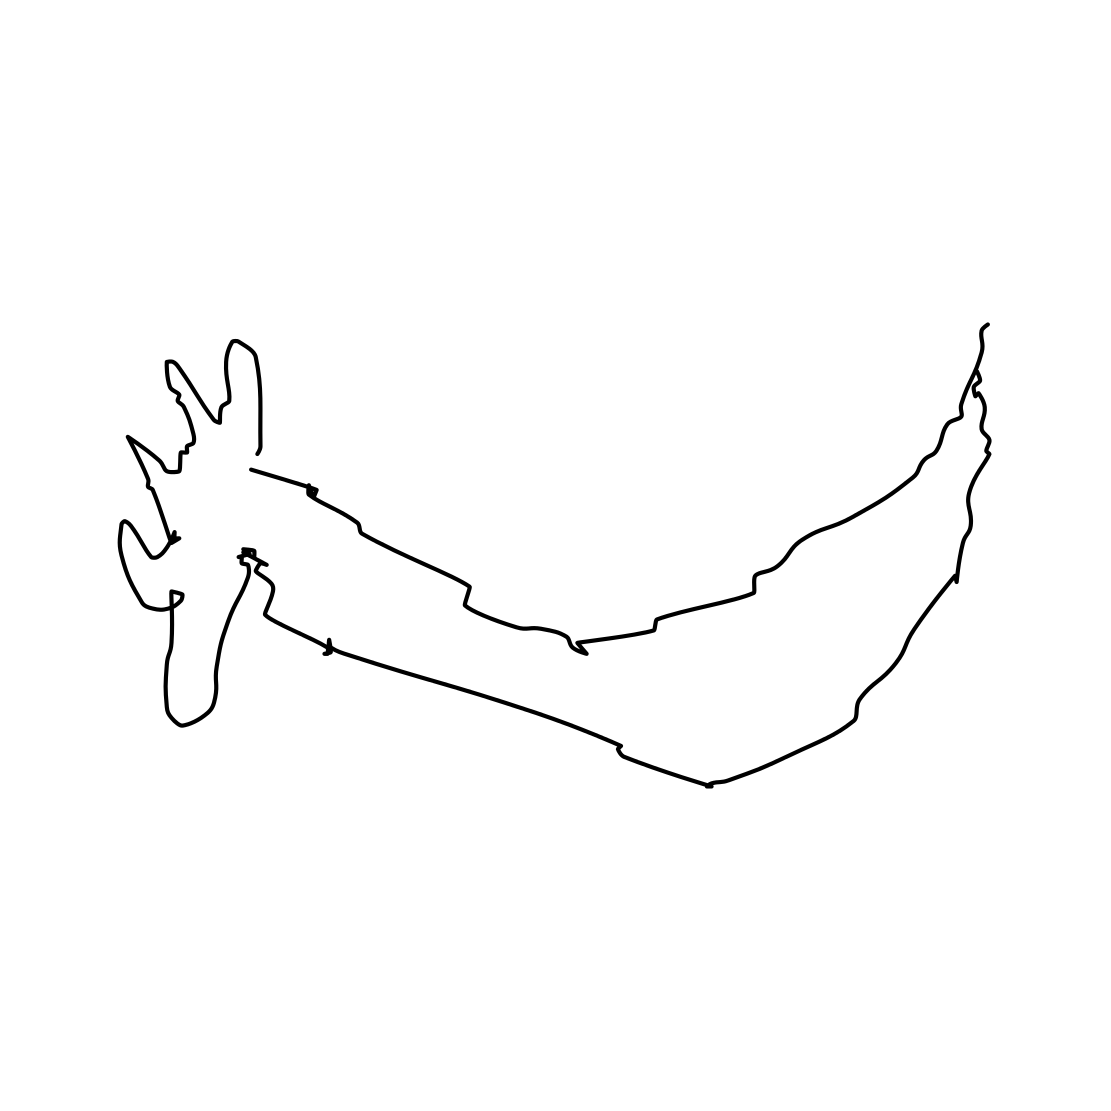Is this a motorbike in the image? No, the image does not depict a motorbike. It is a simple line drawing illustration of a reindeer or a deer with large, branching antlers. The image captures the animal's profile in a stylized, minimalist manner. 